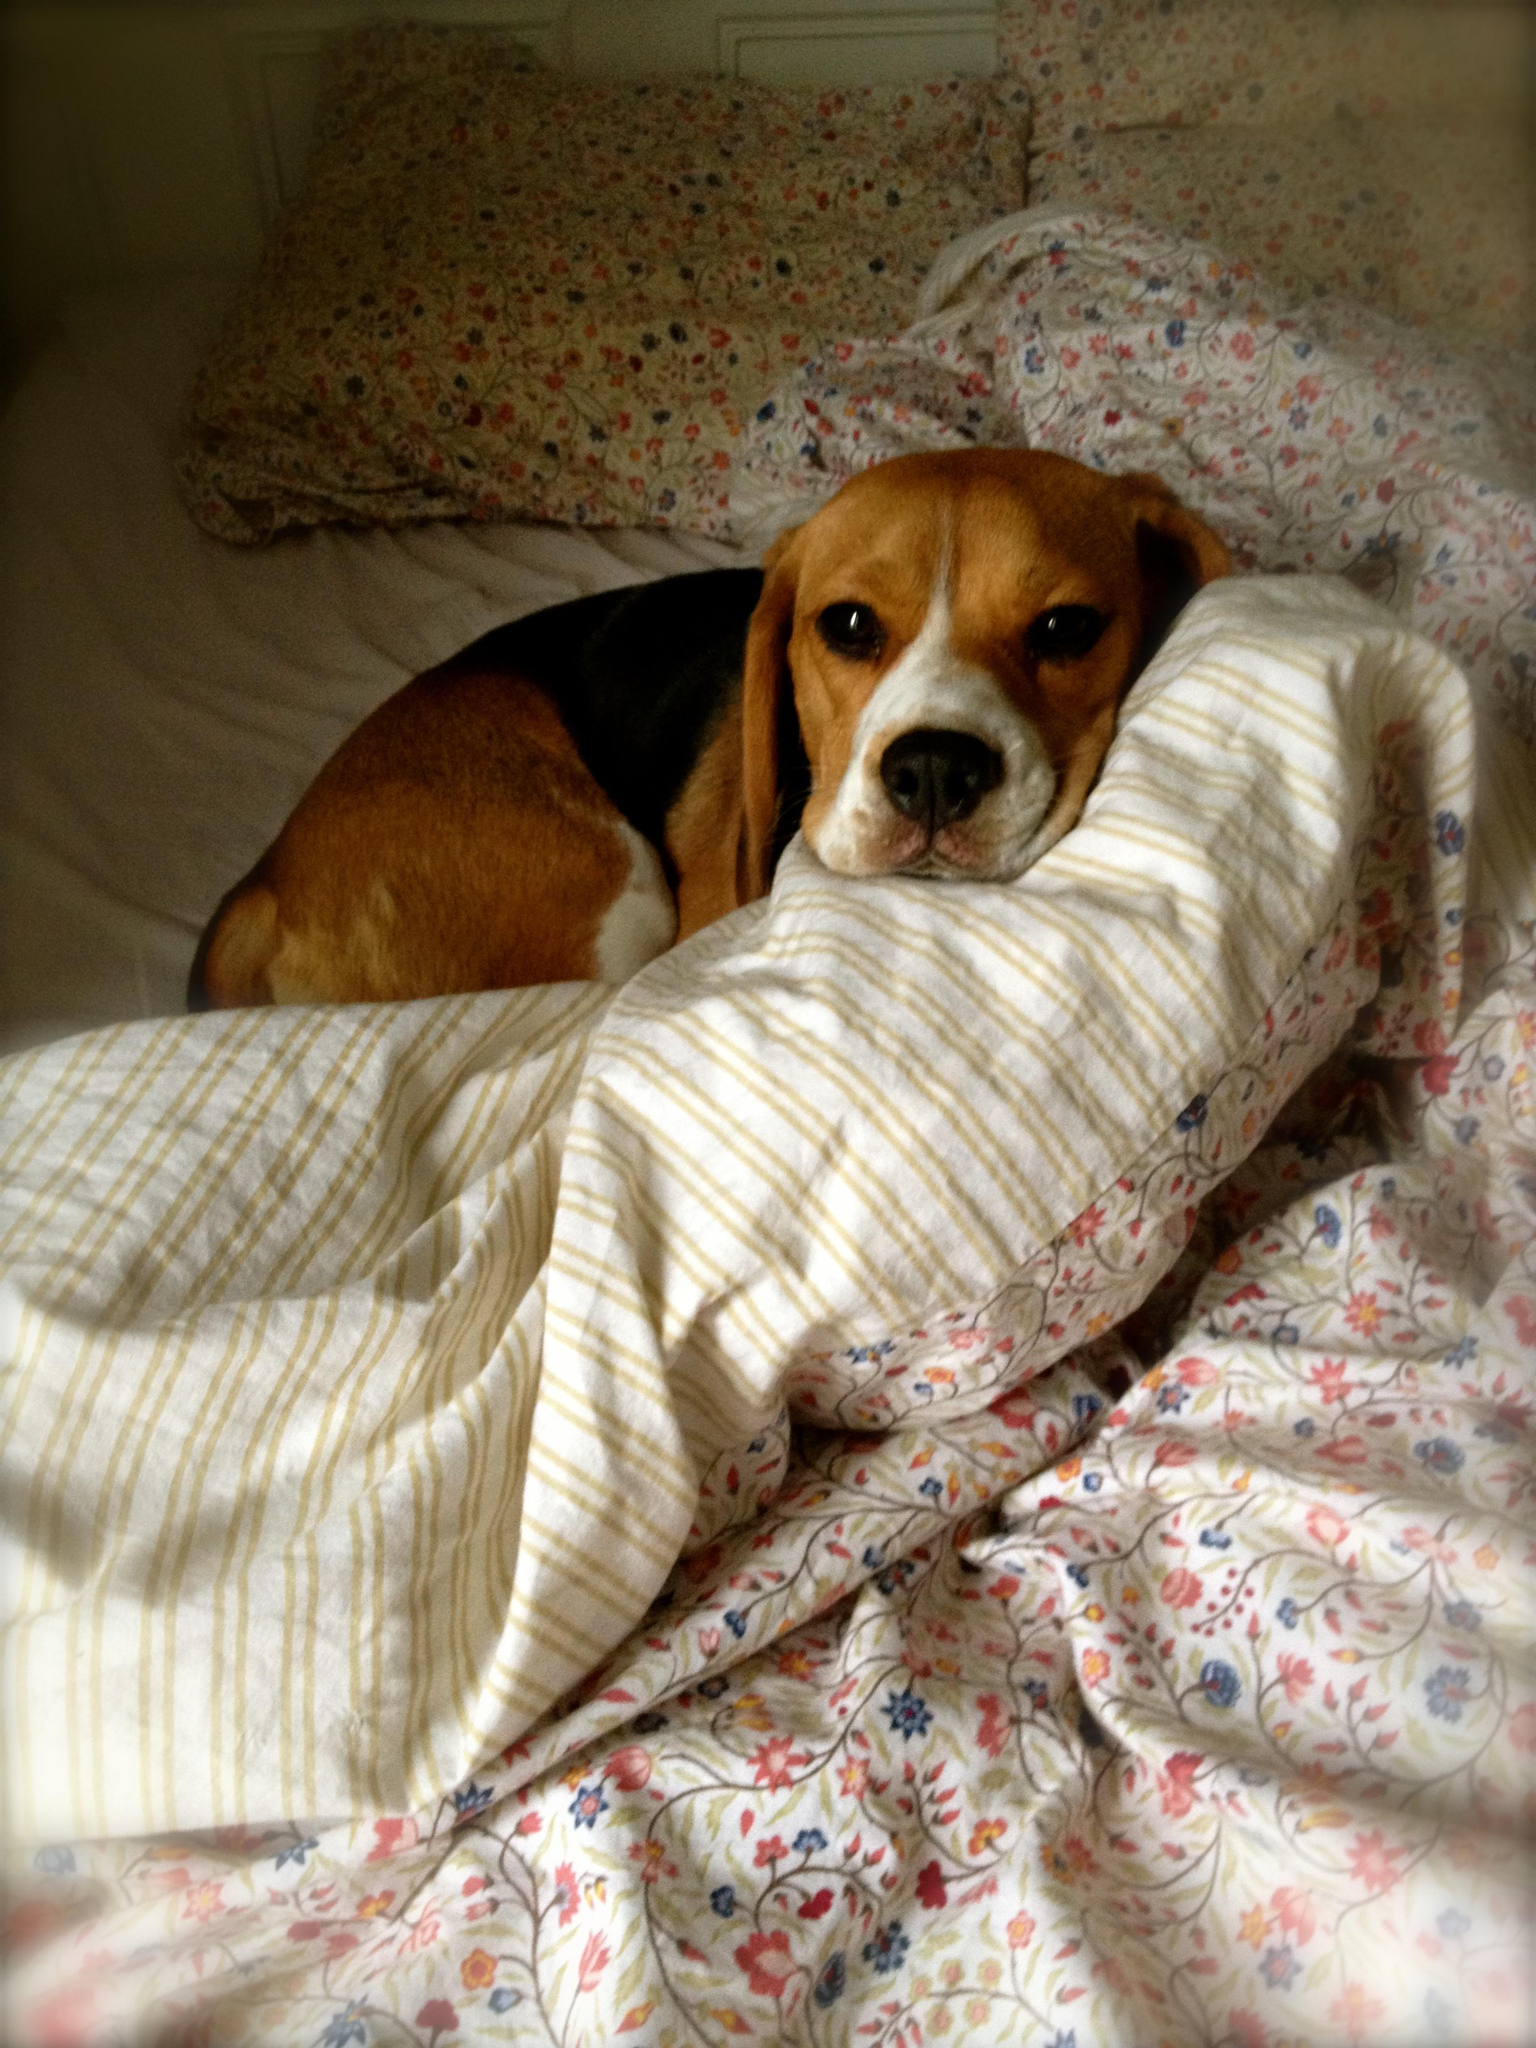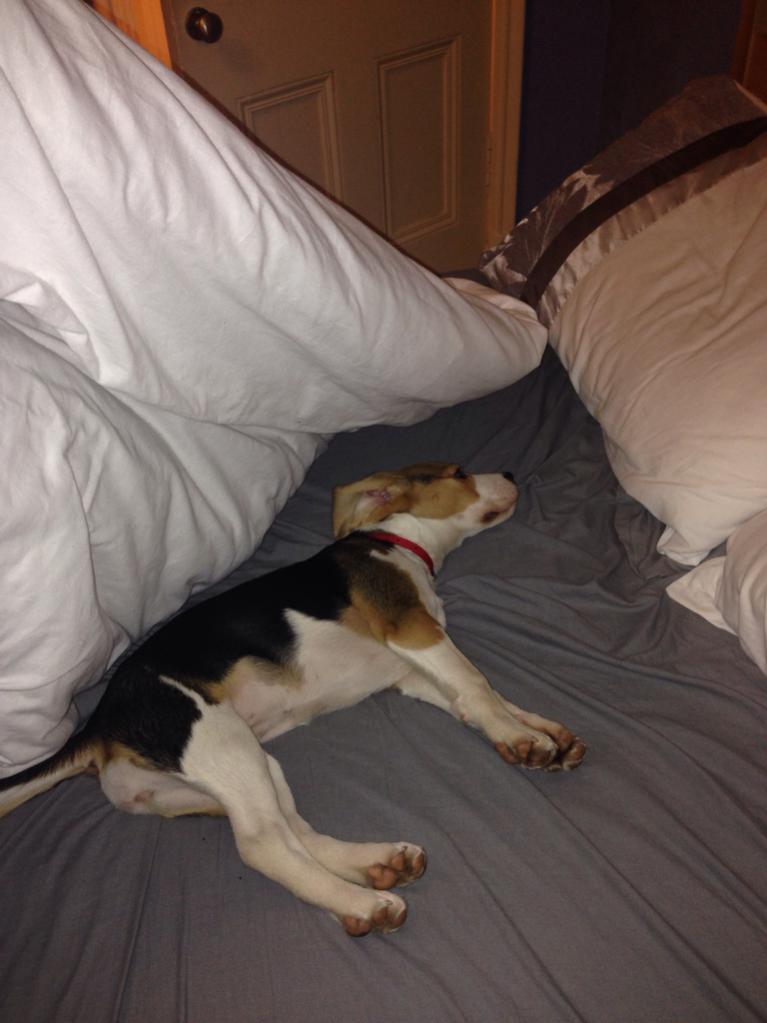The first image is the image on the left, the second image is the image on the right. Given the left and right images, does the statement "There is a one beagle in each picture, all sound asleep." hold true? Answer yes or no. No. The first image is the image on the left, the second image is the image on the right. Considering the images on both sides, is "A dog is sleeping on a couch (sofa)." valid? Answer yes or no. No. 